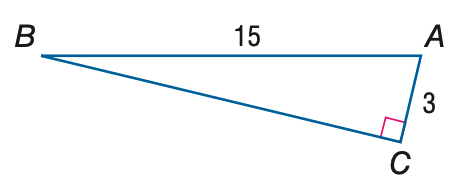Question: Find the measure of \angle A to the nearest tenth.
Choices:
A. 11.3
B. 11.5
C. 78.5
D. 78.7
Answer with the letter. Answer: C 